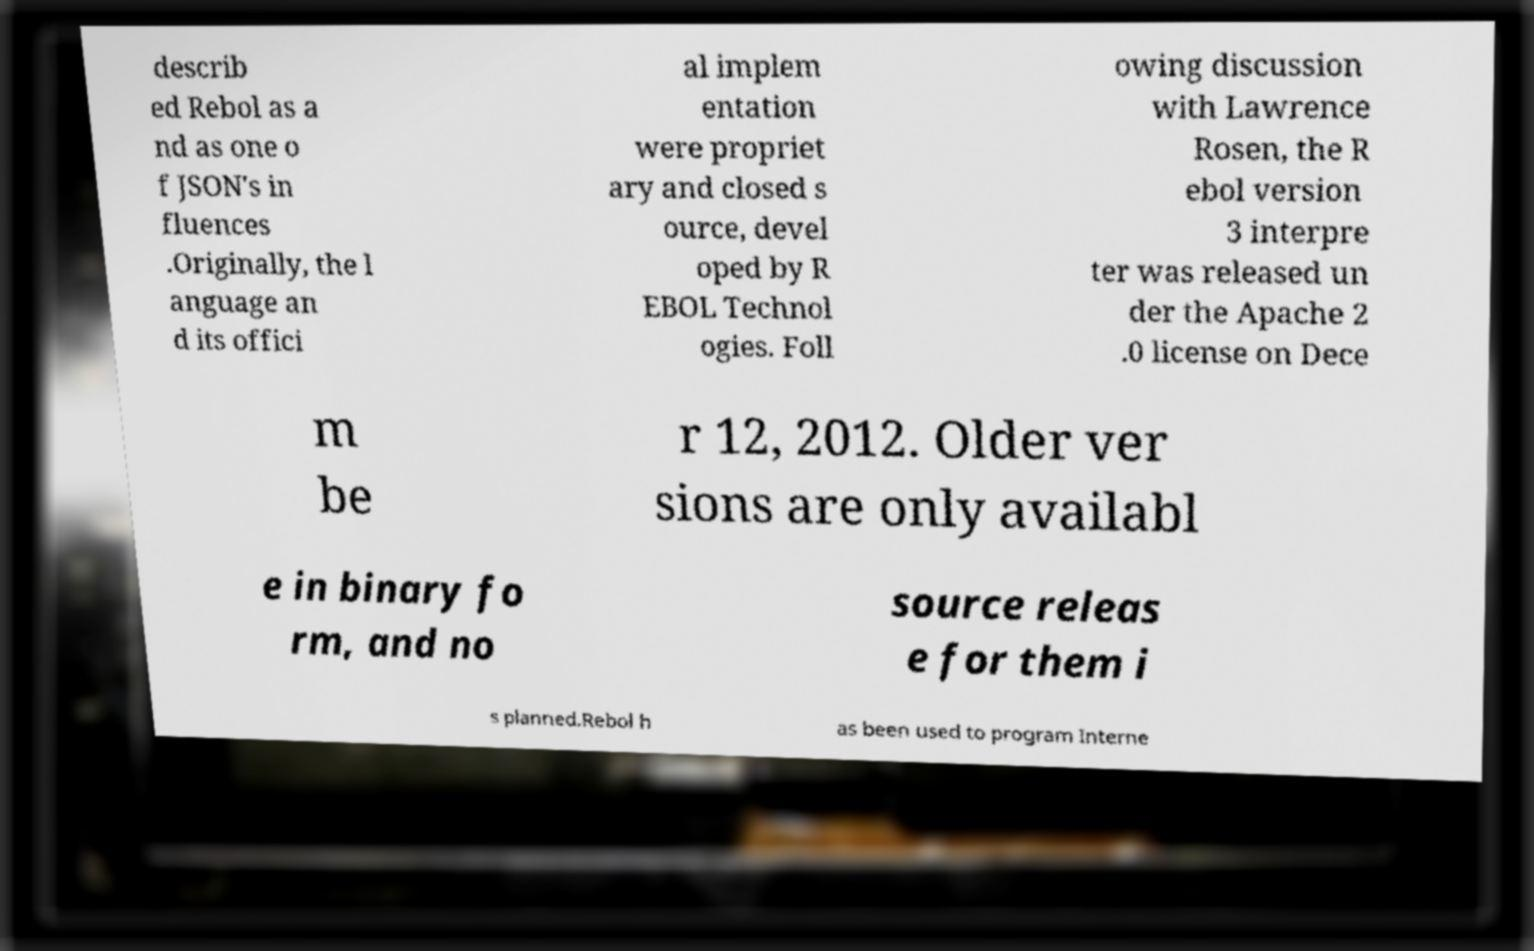Please read and relay the text visible in this image. What does it say? describ ed Rebol as a nd as one o f JSON's in fluences .Originally, the l anguage an d its offici al implem entation were propriet ary and closed s ource, devel oped by R EBOL Technol ogies. Foll owing discussion with Lawrence Rosen, the R ebol version 3 interpre ter was released un der the Apache 2 .0 license on Dece m be r 12, 2012. Older ver sions are only availabl e in binary fo rm, and no source releas e for them i s planned.Rebol h as been used to program Interne 